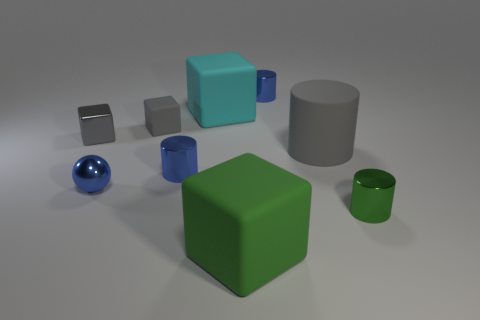Are there more blue shiny cylinders behind the gray rubber cube than cyan matte cubes on the right side of the large cylinder? Yes, there are indeed more blue shiny cylinders behind the gray rubber cube. Upon closer examination, you can see a total of two blue shiny cylinders behind the gray rubber cube, while there is only one cyan matte cube situated to the right of the large gray cylinder. 